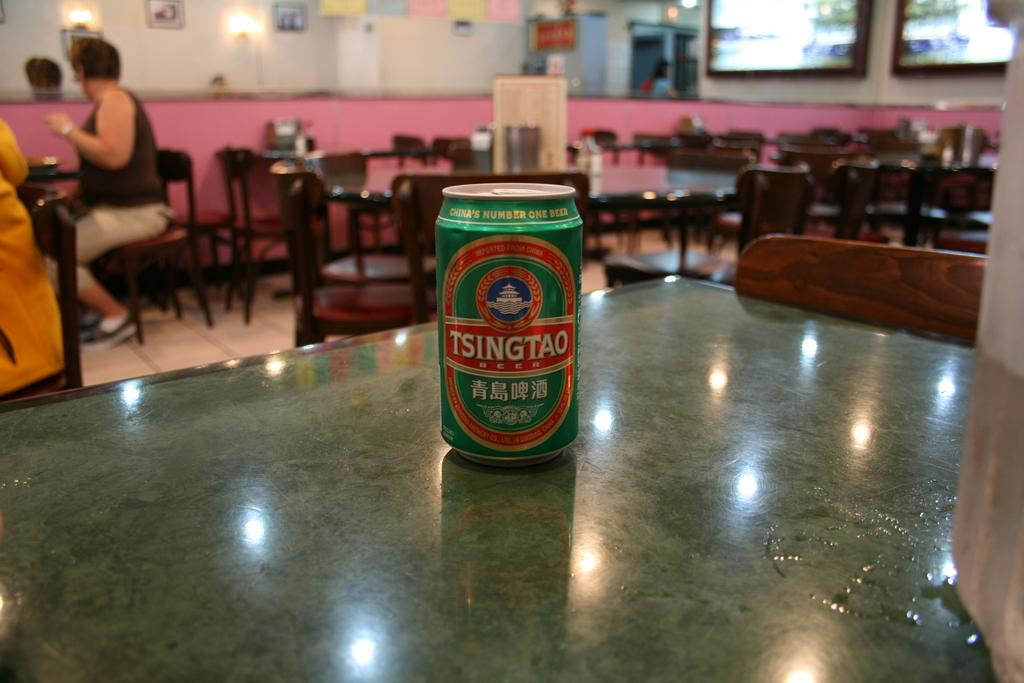<image>
Offer a succinct explanation of the picture presented. Green and red beer can for Tsingtao inside a restaurant. 